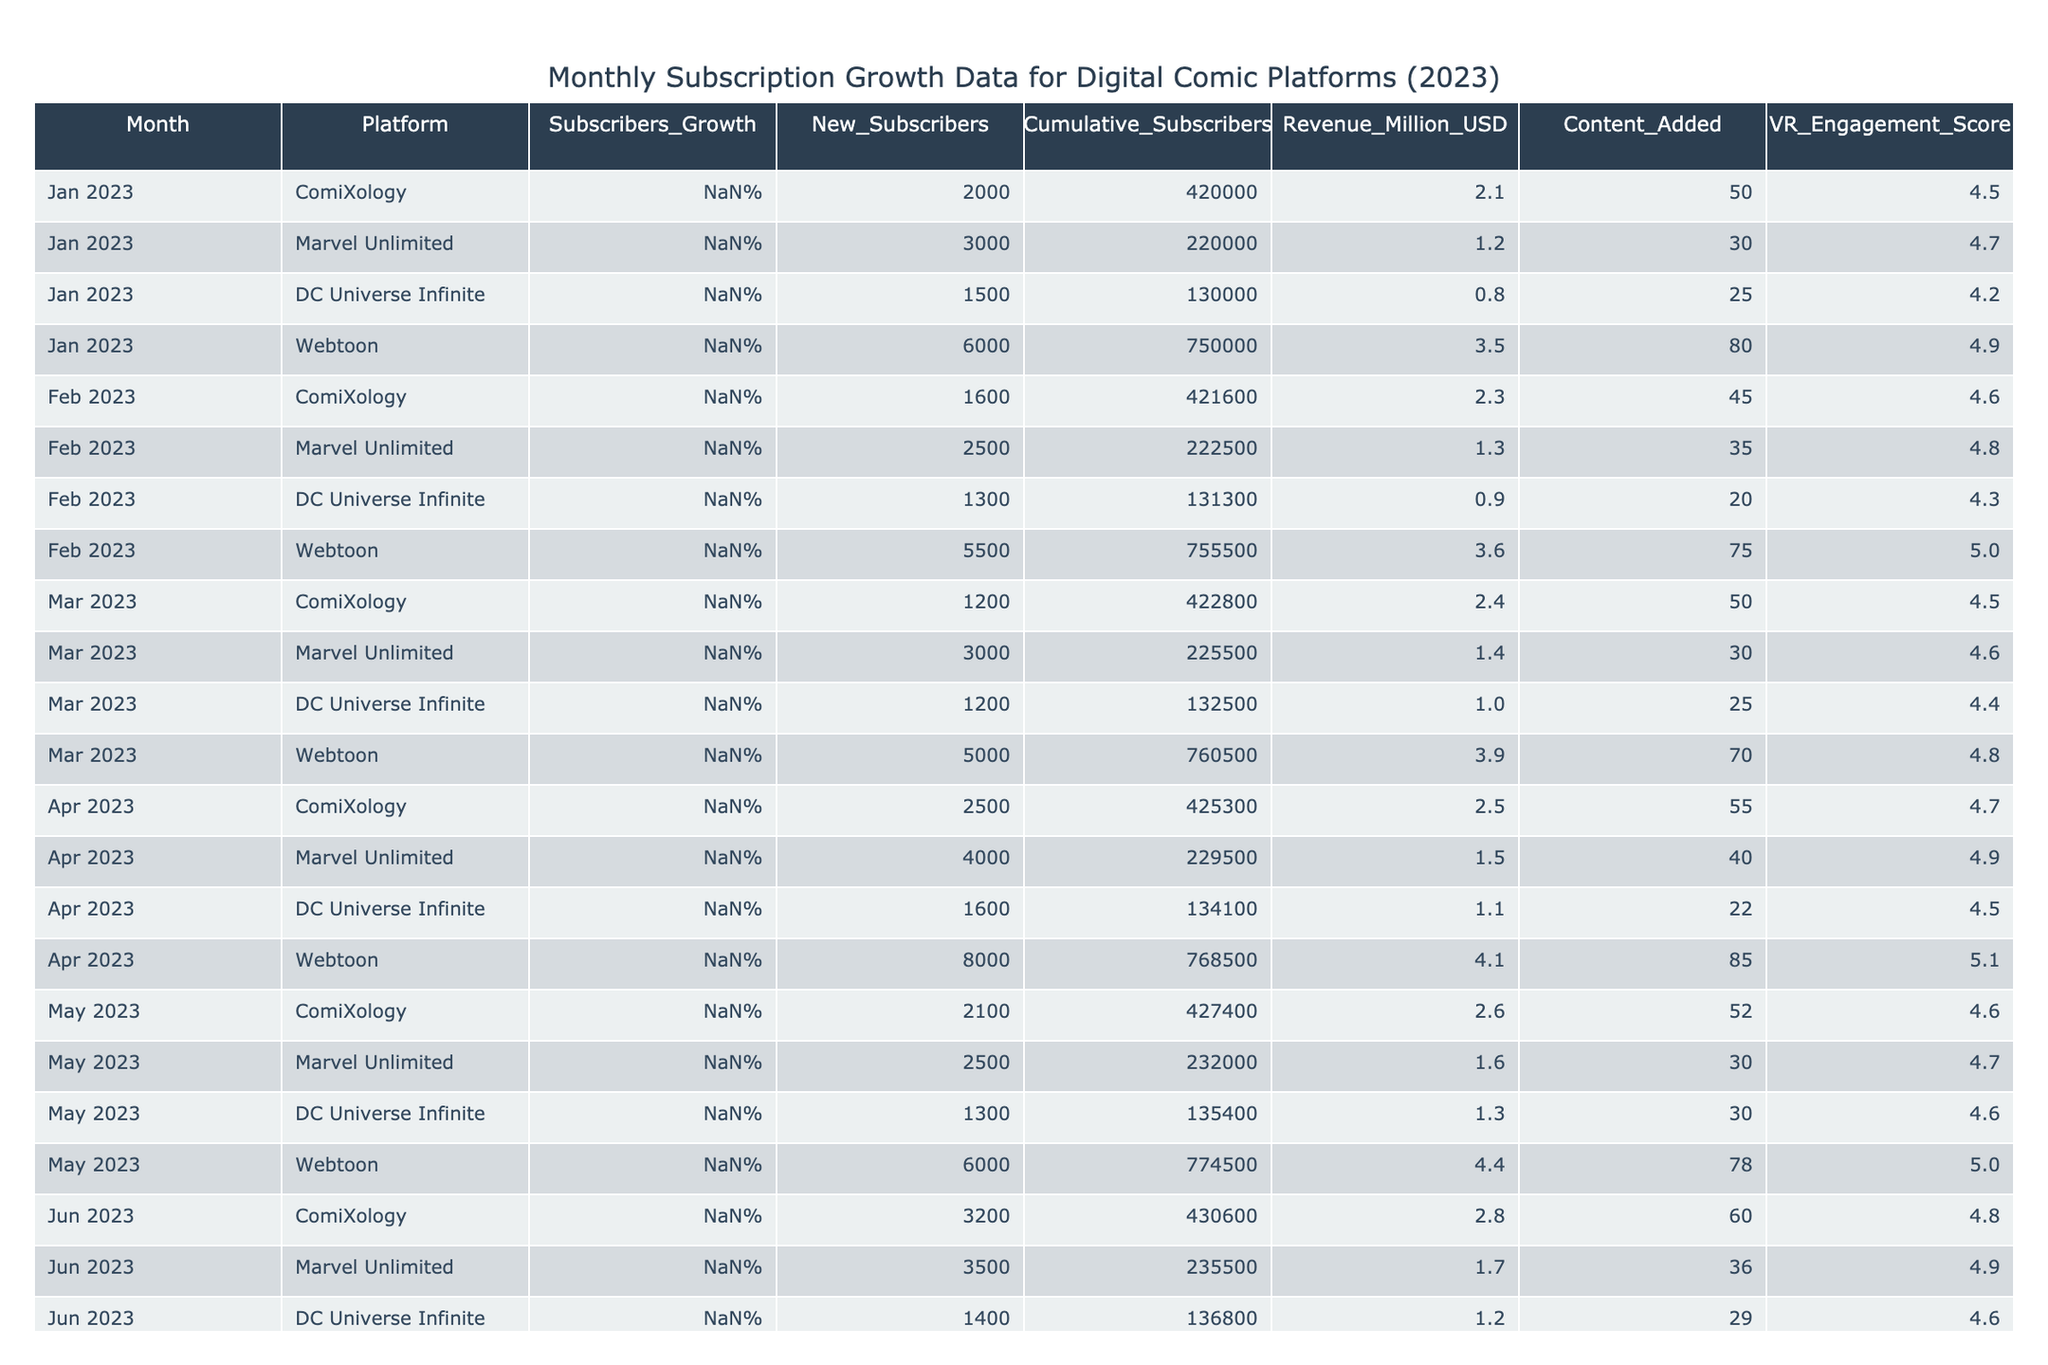What was the cumulative subscriber count for Webtoon in August 2023? The cumulative subscriber count for Webtoon in August 2023 is listed in the table under the "Cumulative_Subscribers" column for that month, which is 797,500.
Answer: 797,500 Which platform had the highest revenue in May 2023? By checking the "Revenue_Million_USD" column for May 2023, Webtoon has the highest revenue of 4.4 million USD compared to ComiXology (2.6 million), Marvel Unlimited (1.6 million), and DC Universe Infinite (1.3 million).
Answer: Webtoon What is the average subscriber growth percentage for DC Universe Infinite from January to April 2023? The subscriber growth percentages for DC Universe Infinite from January to April are 6.0%, 5.5%, 4.5%, and 6.5%. To find the average, we sum these percentages: (6.0 + 5.5 + 4.5 + 6.5) = 22.5, and then divide by 4: 22.5 / 4 = 5.625%.
Answer: 5.625% Did ComiXology show a consistent monthly growth in the number of subscribers from January to October 2023? To determine this, we analyze the "Subscribers_Growth" column for ComiXology. Monthly growth percentages are: 5.0%, 4.0%, 3.5%, 5.5%, 5.0%, 6.5%, 4.0%, 7.5%, 6.2%, 7.0%. The growth fluctuates, with decreases in March and July, indicating inconsistent growth.
Answer: No What was the total number of new subscribers across all platforms for June 2023? The number of new subscribers for each platform in June 2023 is: ComiXology (3,200), Marvel Unlimited (3,500), DC Universe Infinite (1,400), and Webtoon (7,500). Adding these values gives: 3,200 + 3,500 + 1,400 + 7,500 = 15,600.
Answer: 15,600 Which platform had the lowest VR Engagement Score in September 2023? We can see in the "VR_Engagement_Score" column for September 2023 that DC Universe Infinite has the lowest score of 4.7 compared to ComiXology (4.8), Marvel Unlimited (5.0), and Webtoon (5.2).
Answer: DC Universe Infinite How much revenue did Webtoon generate in October 2023 compared to January 2023? The revenue for Webtoon in October 2023 is 5.5 million USD, and for January 2023, it is 3.5 million USD. The difference is 5.5 - 3.5 = 2.0 million USD, indicating an increase.
Answer: 2.0 million USD In which month did Marvel Unlimited achieve its highest number of new subscribers? By reviewing the "New_Subscribers" column for Marvel Unlimited, we find that the highest count is 4,000 in April 2023, compared to other months listed.
Answer: April 2023 What was the average content added per month for Webtoon from January to April 2023? The content added for Webtoon in January is 80, February is 75, March is 70, and April is 85. Summing these gives: 80 + 75 + 70 + 85 = 310. Dividing by 4 gives: 310 / 4 = 77.5.
Answer: 77.5 Which platform consistently had the highest subscriber growth percentage throughout 2023? Analyzing the growth percentages, Webtoon shows the highest growth in January (10.0%), February (9.0%), March (8.5%), April (12.0%), and maintains high growth thereafter, consistently outperforming other platforms.
Answer: Webtoon 